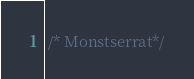<code> <loc_0><loc_0><loc_500><loc_500><_CSS_> /* Monstserrat*/</code> 